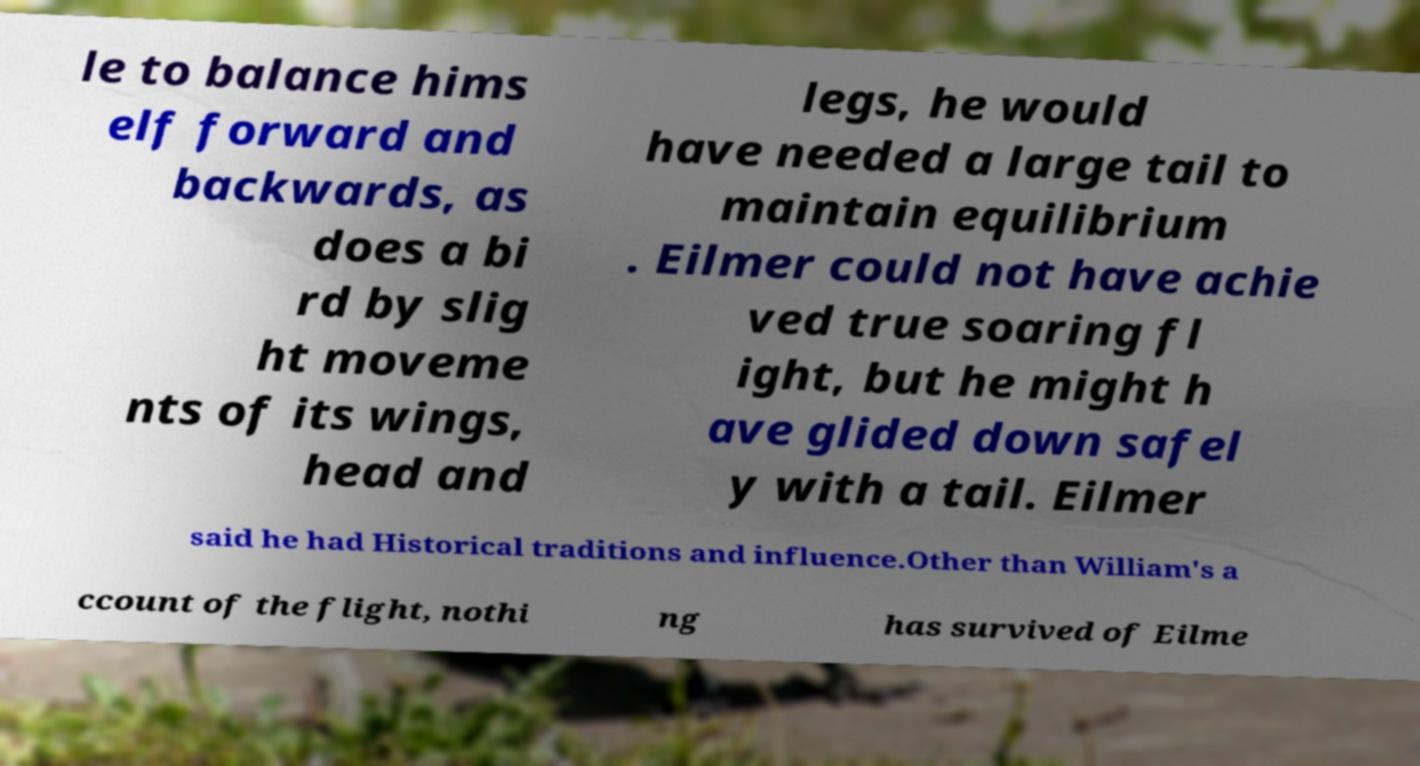Could you extract and type out the text from this image? le to balance hims elf forward and backwards, as does a bi rd by slig ht moveme nts of its wings, head and legs, he would have needed a large tail to maintain equilibrium . Eilmer could not have achie ved true soaring fl ight, but he might h ave glided down safel y with a tail. Eilmer said he had Historical traditions and influence.Other than William's a ccount of the flight, nothi ng has survived of Eilme 